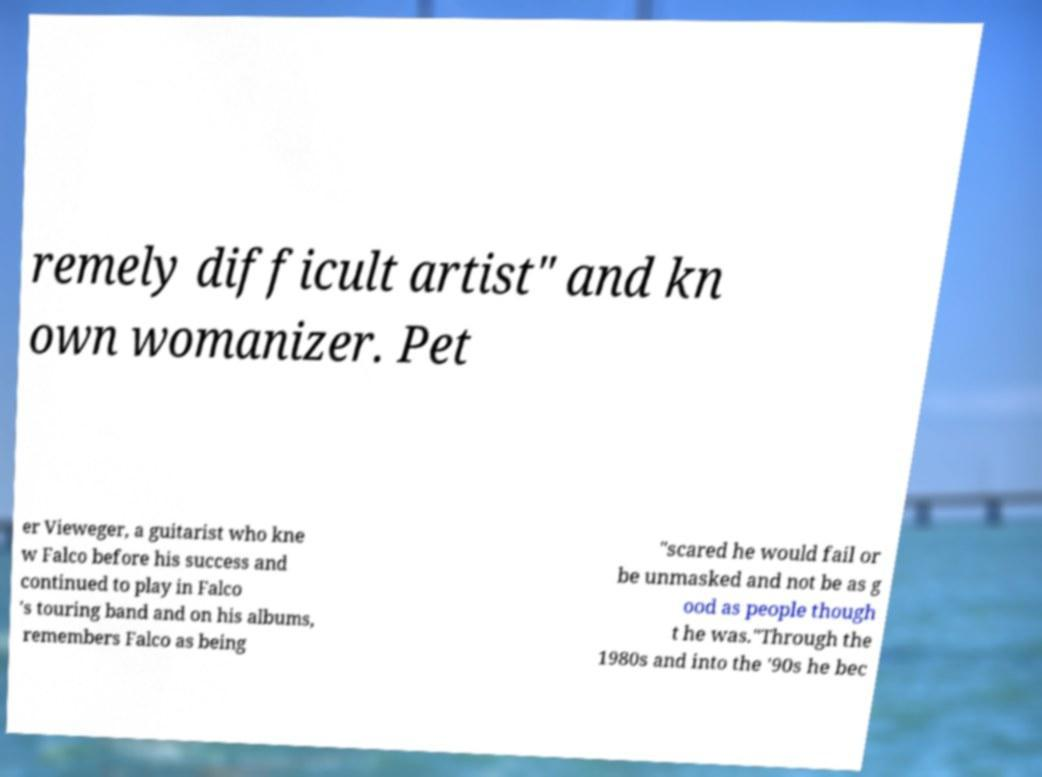Can you read and provide the text displayed in the image?This photo seems to have some interesting text. Can you extract and type it out for me? remely difficult artist" and kn own womanizer. Pet er Vieweger, a guitarist who kne w Falco before his success and continued to play in Falco 's touring band and on his albums, remembers Falco as being "scared he would fail or be unmasked and not be as g ood as people though t he was."Through the 1980s and into the '90s he bec 